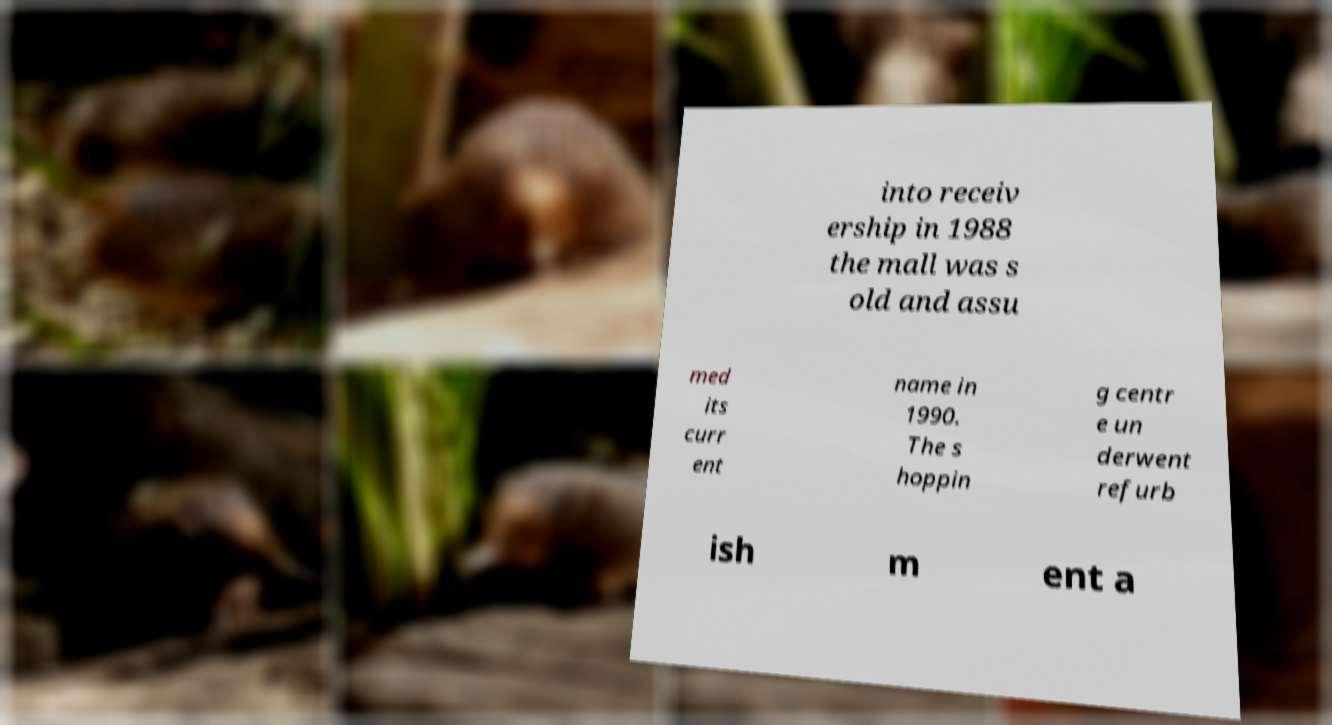Could you extract and type out the text from this image? into receiv ership in 1988 the mall was s old and assu med its curr ent name in 1990. The s hoppin g centr e un derwent refurb ish m ent a 